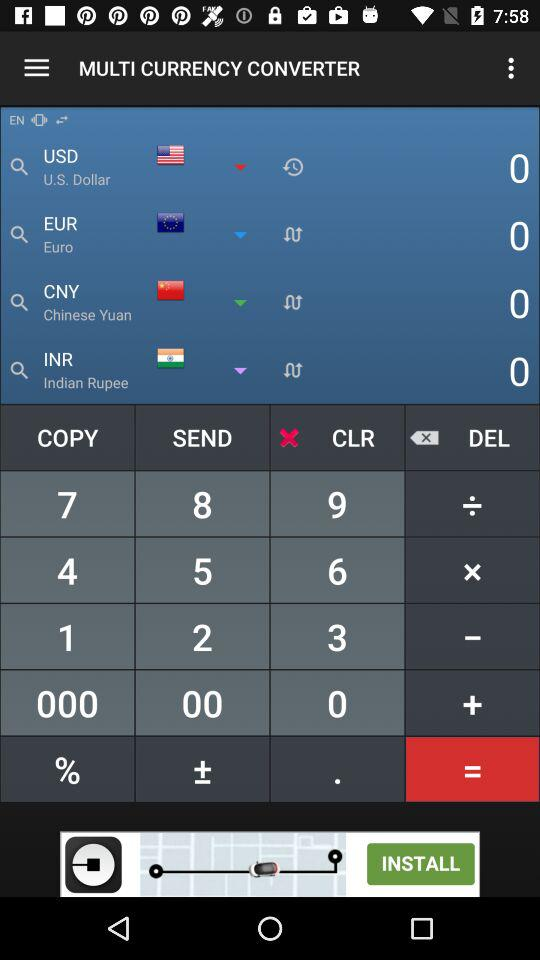What is the short form of the Indian rupee? The short form of the Indian rupee is INR. 